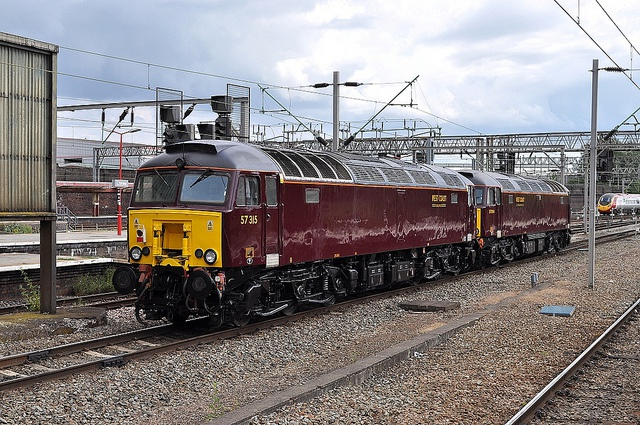Describe the objects in this image and their specific colors. I can see train in lavender, black, maroon, gray, and darkgray tones and train in lavender, lightgray, darkgray, gray, and black tones in this image. 